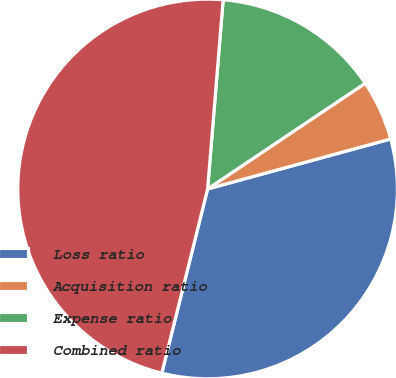Convert chart. <chart><loc_0><loc_0><loc_500><loc_500><pie_chart><fcel>Loss ratio<fcel>Acquisition ratio<fcel>Expense ratio<fcel>Combined ratio<nl><fcel>33.12%<fcel>5.16%<fcel>14.29%<fcel>47.42%<nl></chart> 